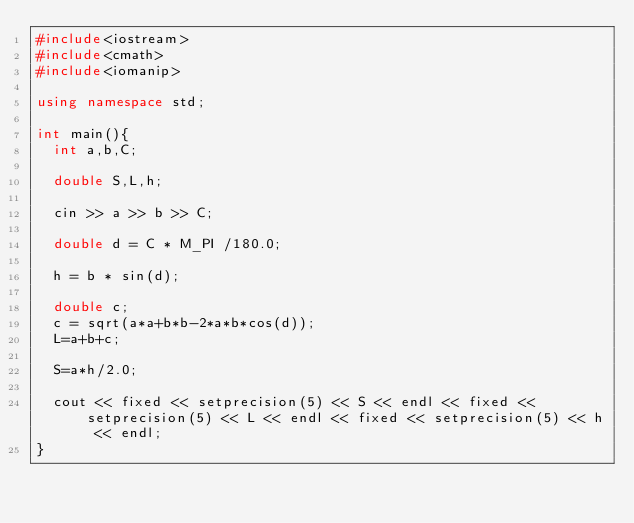<code> <loc_0><loc_0><loc_500><loc_500><_C++_>#include<iostream>
#include<cmath>
#include<iomanip>

using namespace std;

int main(){
  int a,b,C;

  double S,L,h;

  cin >> a >> b >> C;

  double d = C * M_PI /180.0;

  h = b * sin(d);

  double c;
  c = sqrt(a*a+b*b-2*a*b*cos(d));
  L=a+b+c;

  S=a*h/2.0;

  cout << fixed << setprecision(5) << S << endl << fixed << setprecision(5) << L << endl << fixed << setprecision(5) << h << endl;
}</code> 